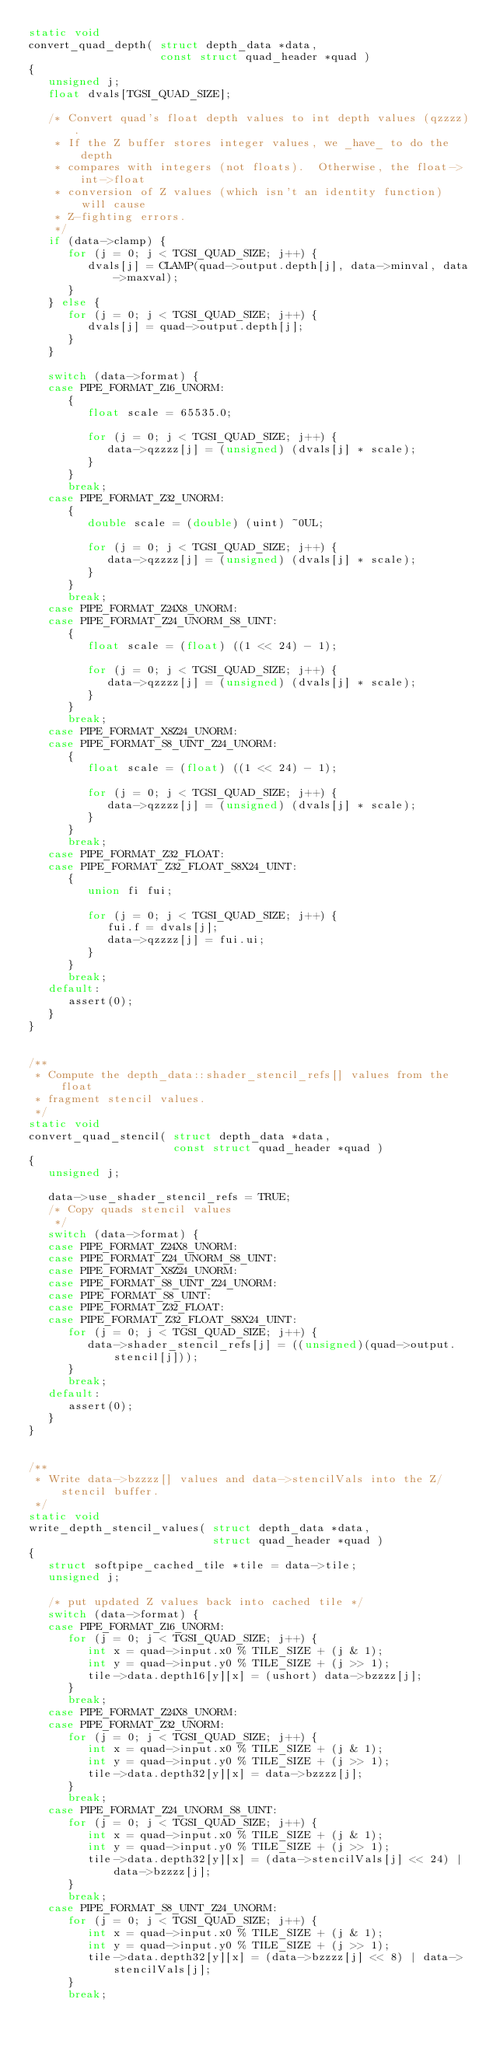Convert code to text. <code><loc_0><loc_0><loc_500><loc_500><_C_>static void
convert_quad_depth( struct depth_data *data, 
                    const struct quad_header *quad )
{
   unsigned j;
   float dvals[TGSI_QUAD_SIZE];

   /* Convert quad's float depth values to int depth values (qzzzz).
    * If the Z buffer stores integer values, we _have_ to do the depth
    * compares with integers (not floats).  Otherwise, the float->int->float
    * conversion of Z values (which isn't an identity function) will cause
    * Z-fighting errors.
    */
   if (data->clamp) {
      for (j = 0; j < TGSI_QUAD_SIZE; j++) {
         dvals[j] = CLAMP(quad->output.depth[j], data->minval, data->maxval);
      }
   } else {
      for (j = 0; j < TGSI_QUAD_SIZE; j++) {
         dvals[j] = quad->output.depth[j];
      }
   }

   switch (data->format) {
   case PIPE_FORMAT_Z16_UNORM:
      {
         float scale = 65535.0;

         for (j = 0; j < TGSI_QUAD_SIZE; j++) {
            data->qzzzz[j] = (unsigned) (dvals[j] * scale);
         }
      }
      break;
   case PIPE_FORMAT_Z32_UNORM:
      {
         double scale = (double) (uint) ~0UL;

         for (j = 0; j < TGSI_QUAD_SIZE; j++) {
            data->qzzzz[j] = (unsigned) (dvals[j] * scale);
         }
      }
      break;
   case PIPE_FORMAT_Z24X8_UNORM:
   case PIPE_FORMAT_Z24_UNORM_S8_UINT:
      {
         float scale = (float) ((1 << 24) - 1);

         for (j = 0; j < TGSI_QUAD_SIZE; j++) {
            data->qzzzz[j] = (unsigned) (dvals[j] * scale);
         }
      }
      break;
   case PIPE_FORMAT_X8Z24_UNORM:
   case PIPE_FORMAT_S8_UINT_Z24_UNORM:
      {
         float scale = (float) ((1 << 24) - 1);

         for (j = 0; j < TGSI_QUAD_SIZE; j++) {
            data->qzzzz[j] = (unsigned) (dvals[j] * scale);
         }
      }
      break;
   case PIPE_FORMAT_Z32_FLOAT:
   case PIPE_FORMAT_Z32_FLOAT_S8X24_UINT:
      {
         union fi fui;

         for (j = 0; j < TGSI_QUAD_SIZE; j++) {
            fui.f = dvals[j];
            data->qzzzz[j] = fui.ui;
         }
      }
      break;
   default:
      assert(0);
   }
}


/**
 * Compute the depth_data::shader_stencil_refs[] values from the float
 * fragment stencil values.
 */
static void
convert_quad_stencil( struct depth_data *data, 
                      const struct quad_header *quad )
{
   unsigned j;

   data->use_shader_stencil_refs = TRUE;
   /* Copy quads stencil values
    */
   switch (data->format) {
   case PIPE_FORMAT_Z24X8_UNORM:
   case PIPE_FORMAT_Z24_UNORM_S8_UINT:
   case PIPE_FORMAT_X8Z24_UNORM:
   case PIPE_FORMAT_S8_UINT_Z24_UNORM:
   case PIPE_FORMAT_S8_UINT:
   case PIPE_FORMAT_Z32_FLOAT:
   case PIPE_FORMAT_Z32_FLOAT_S8X24_UINT:
      for (j = 0; j < TGSI_QUAD_SIZE; j++) {
         data->shader_stencil_refs[j] = ((unsigned)(quad->output.stencil[j]));
      }
      break;
   default:
      assert(0);
   }
}


/**
 * Write data->bzzzz[] values and data->stencilVals into the Z/stencil buffer.
 */
static void
write_depth_stencil_values( struct depth_data *data,
                            struct quad_header *quad )
{
   struct softpipe_cached_tile *tile = data->tile;
   unsigned j;

   /* put updated Z values back into cached tile */
   switch (data->format) {
   case PIPE_FORMAT_Z16_UNORM:
      for (j = 0; j < TGSI_QUAD_SIZE; j++) {
         int x = quad->input.x0 % TILE_SIZE + (j & 1);
         int y = quad->input.y0 % TILE_SIZE + (j >> 1);
         tile->data.depth16[y][x] = (ushort) data->bzzzz[j];
      }
      break;
   case PIPE_FORMAT_Z24X8_UNORM:
   case PIPE_FORMAT_Z32_UNORM:
      for (j = 0; j < TGSI_QUAD_SIZE; j++) {
         int x = quad->input.x0 % TILE_SIZE + (j & 1);
         int y = quad->input.y0 % TILE_SIZE + (j >> 1);
         tile->data.depth32[y][x] = data->bzzzz[j];
      }
      break;
   case PIPE_FORMAT_Z24_UNORM_S8_UINT:
      for (j = 0; j < TGSI_QUAD_SIZE; j++) {
         int x = quad->input.x0 % TILE_SIZE + (j & 1);
         int y = quad->input.y0 % TILE_SIZE + (j >> 1);
         tile->data.depth32[y][x] = (data->stencilVals[j] << 24) | data->bzzzz[j];
      }
      break;
   case PIPE_FORMAT_S8_UINT_Z24_UNORM:
      for (j = 0; j < TGSI_QUAD_SIZE; j++) {
         int x = quad->input.x0 % TILE_SIZE + (j & 1);
         int y = quad->input.y0 % TILE_SIZE + (j >> 1);
         tile->data.depth32[y][x] = (data->bzzzz[j] << 8) | data->stencilVals[j];
      }
      break;</code> 